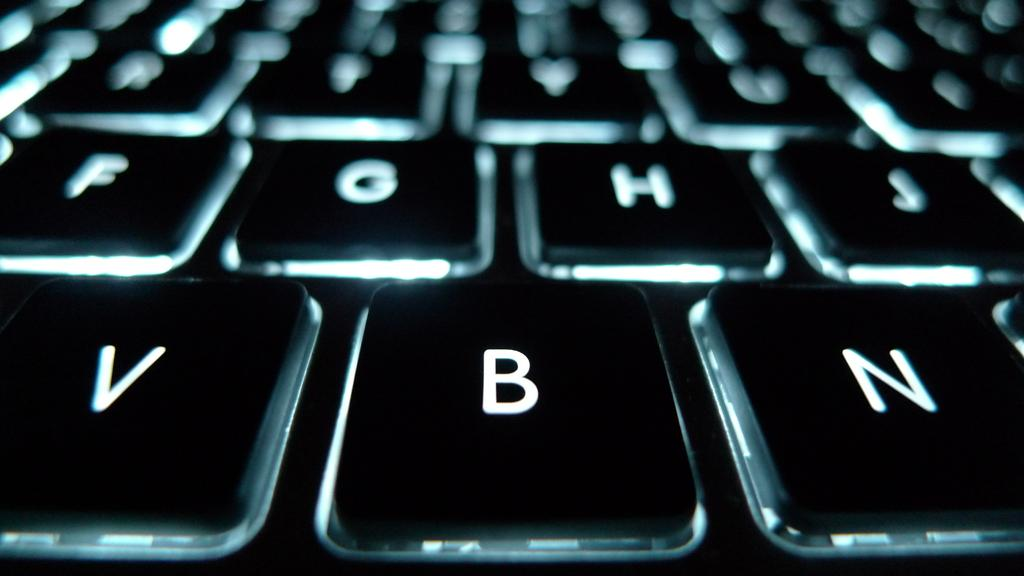<image>
Share a concise interpretation of the image provided. a close up of a keyboard with VBN at the bottom 